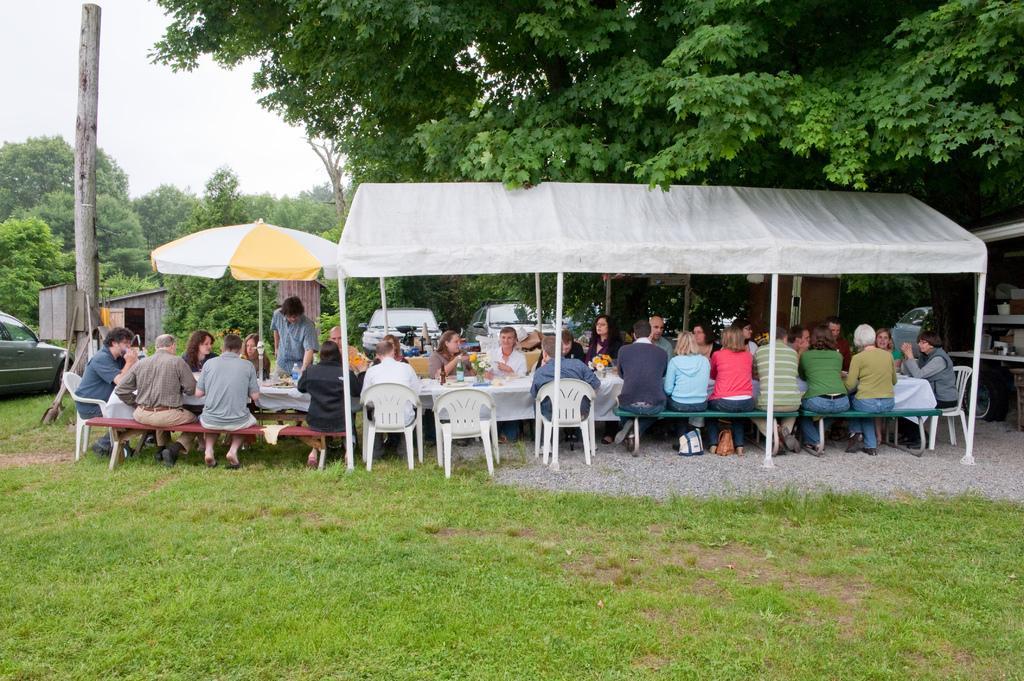In one or two sentences, can you explain what this image depicts? There are group of people sitting on the chairs and bench. Here is a person standing. This is a tent which is white in color. This is the table covered with white cloth. These are the flower vases,water bottle and some things placed on the table. I can see bags under the bench. There are three cars which are parked. These are trees. I can see vehicle wheel. This is an umbrella. This looks like a wooden shelter. 